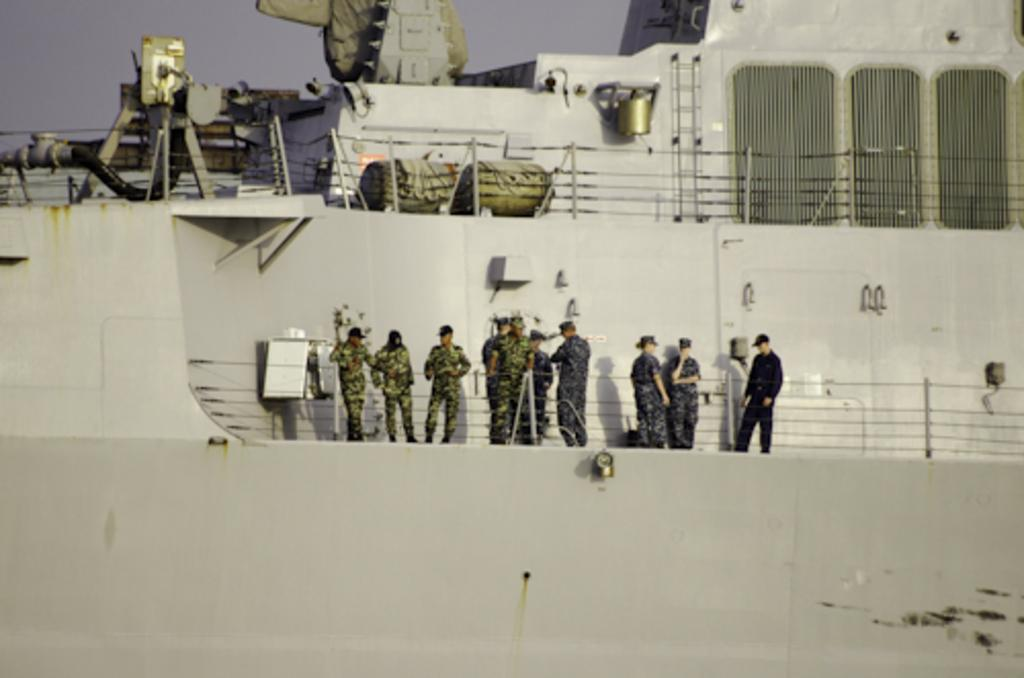What type of vehicle is in the image? There is a grey ship in the image. What are the people in the image doing? There are people standing in the middle of the ship. What can be seen above the ship? There are railings, pipes, and other unspecified items visible above the ship. What type of writing can be seen on the side of the ship? There is no writing visible on the side of the ship in the image. 